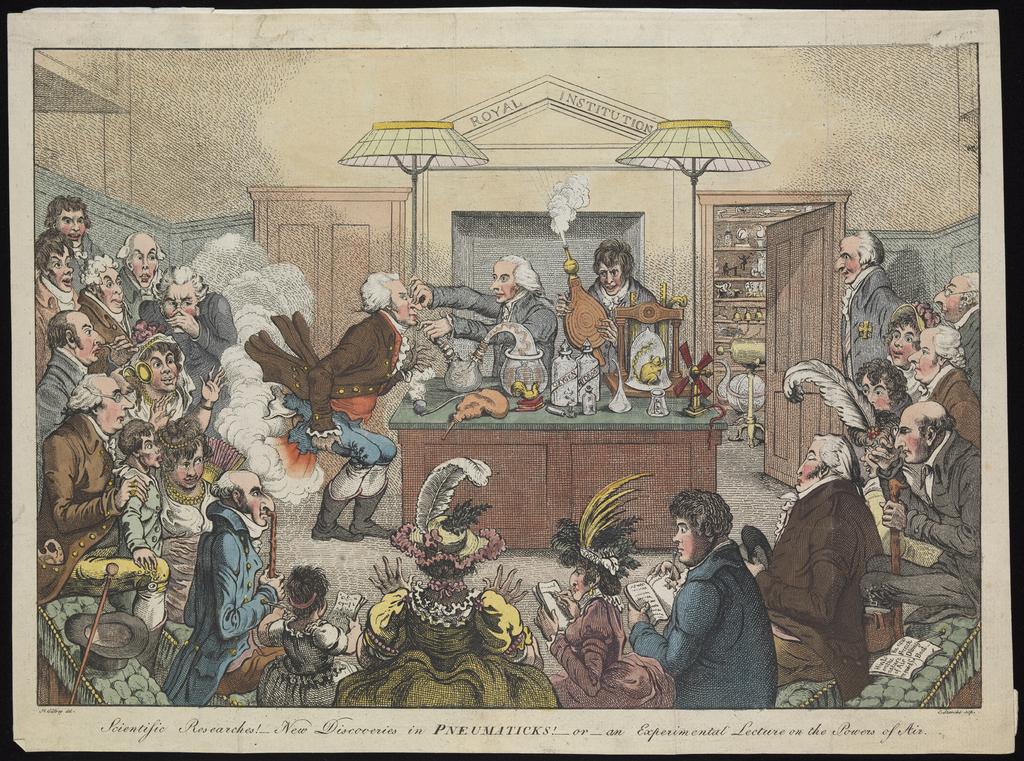What does it say between the two lamps at the top?
Provide a succinct answer. Royal institution. 